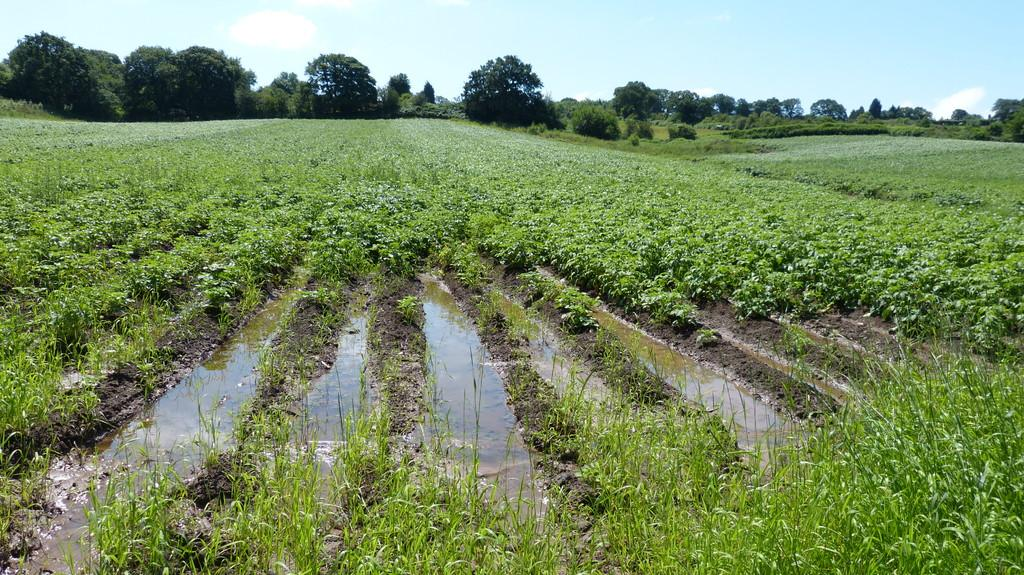What can be seen in the left corner of the image? There are plants in the left corner of the image. What can be seen in the right corner of the image? There are plants in the right corner of the image. What is located in the middle of the image? There is water in the middle of the image. What type of vegetation is visible in the background of the image? There are trees in the background of the image. What is visible at the top of the image? The sky is visible at the top of the image. How many times is the wrench used to break the ice in the image? There is no wrench or ice present in the image. What type of ice is visible in the image? There is no ice present in the image. 